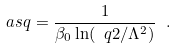<formula> <loc_0><loc_0><loc_500><loc_500>\ a s q = \frac { 1 } { \beta _ { 0 } \ln ( \ q 2 / \Lambda ^ { 2 } ) } \ .</formula> 